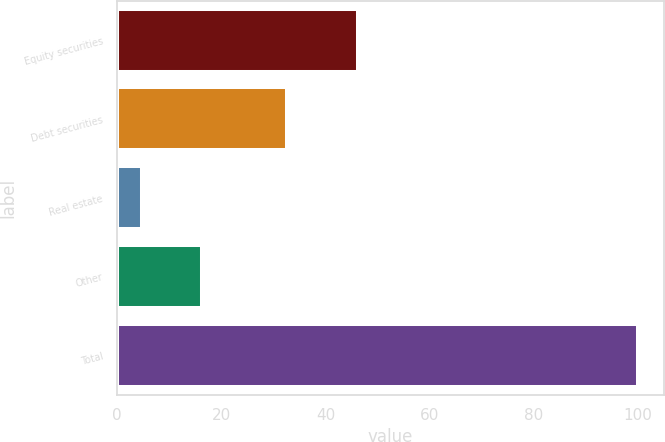Convert chart. <chart><loc_0><loc_0><loc_500><loc_500><bar_chart><fcel>Equity securities<fcel>Debt securities<fcel>Real estate<fcel>Other<fcel>Total<nl><fcel>46.3<fcel>32.7<fcel>4.8<fcel>16.2<fcel>100<nl></chart> 